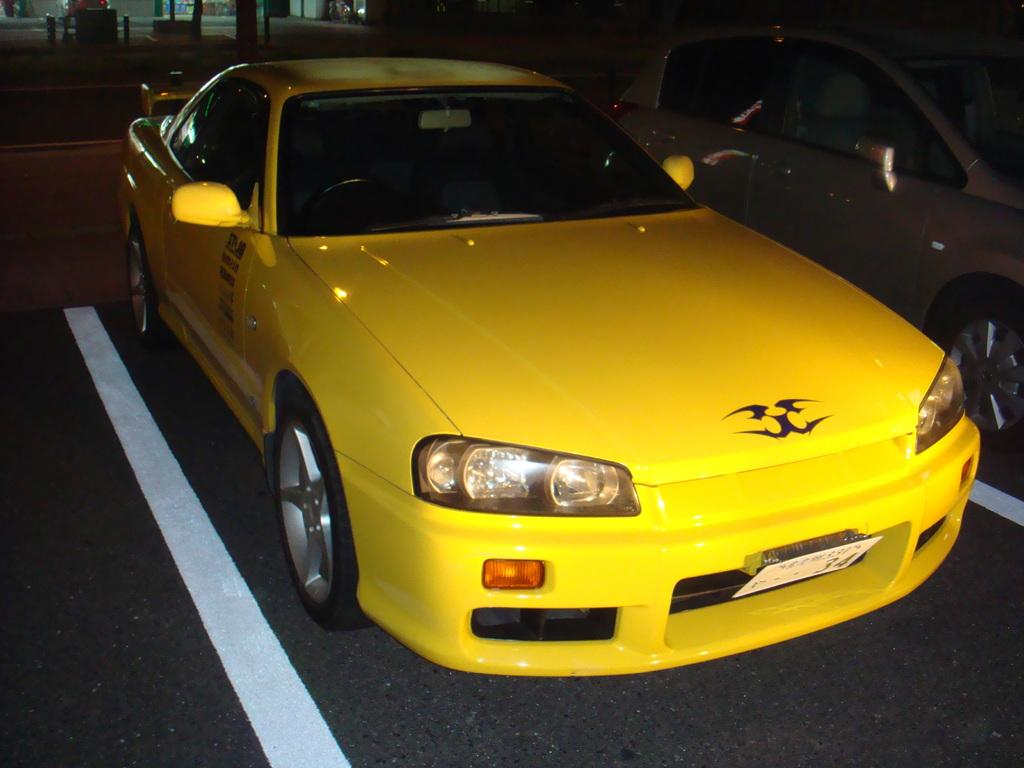What is the main subject of the image? The main subject of the image is a car. Can you describe the car in the image? The car is yellow. What can be seen in the background of the image? There are poles and stalls in the background of the image. Are there any other cars visible in the image? Yes, there is another car visible in the image. What type of pollution can be seen coming from the car in the image? There is no indication of pollution in the image, as the car appears to be stationary and not emitting any visible exhaust. 